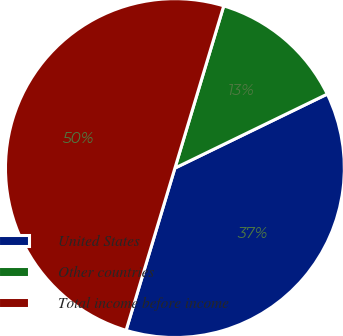Convert chart. <chart><loc_0><loc_0><loc_500><loc_500><pie_chart><fcel>United States<fcel>Other countries<fcel>Total income before income<nl><fcel>36.85%<fcel>13.15%<fcel>50.0%<nl></chart> 